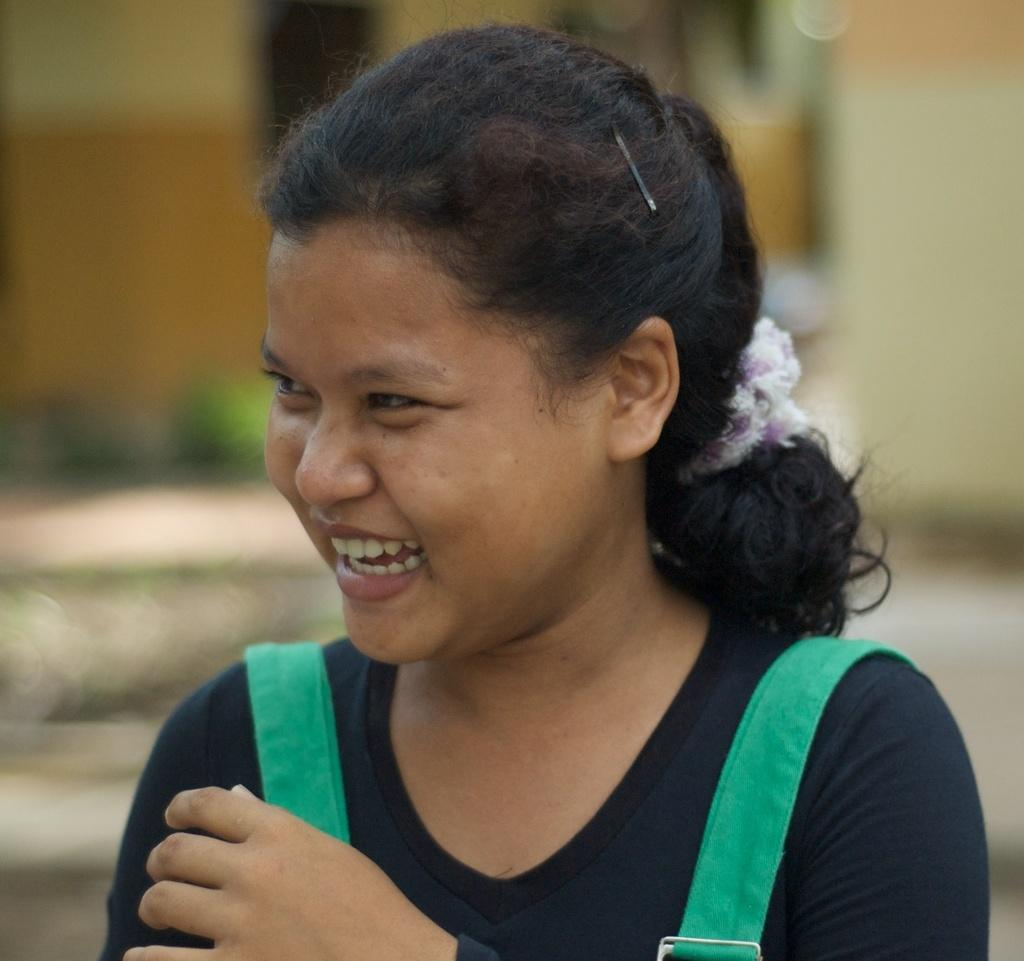Who is present in the image? There is a lady in the image. What is the lady doing in the image? The lady is laughing. Can you describe the background of the image? The background of the image is blurred. What type of war is depicted in the image? There is no war depicted in the image; it features a lady laughing with a blurred background. Is there a camp visible in the image? There is no camp present in the image. 